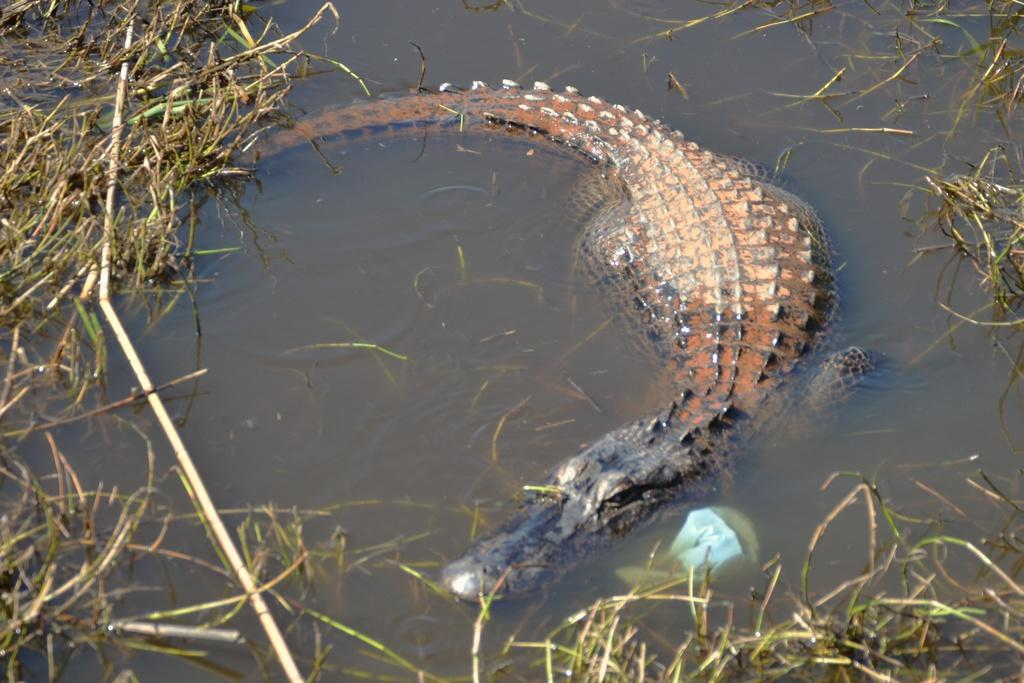What animal is present in the image? There is a crocodile in the image. What is the environment like in the image? The environment includes water and plants. How many planes can be seen flying over the crocodile in the image? There are no planes visible in the image; it only features a crocodile and plants in the water. 